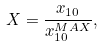<formula> <loc_0><loc_0><loc_500><loc_500>X = \frac { x _ { 1 0 } } { x _ { 1 0 } ^ { M A X } } ,</formula> 